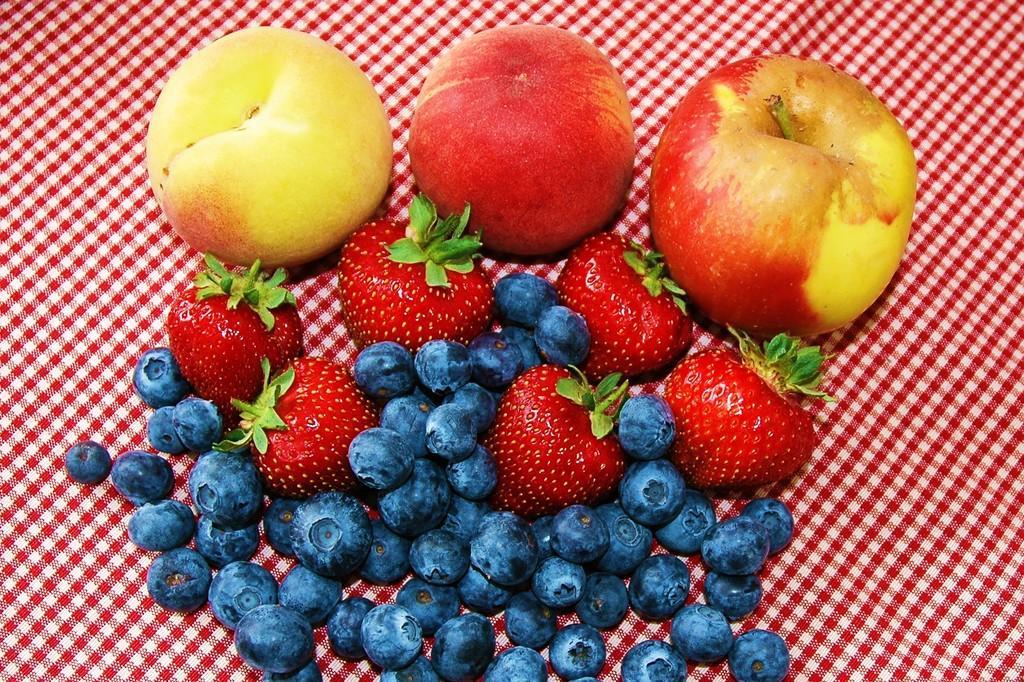Describe this image in one or two sentences. There are the apples and in the middle there are strawberries. In the down side there are black color grapes. 